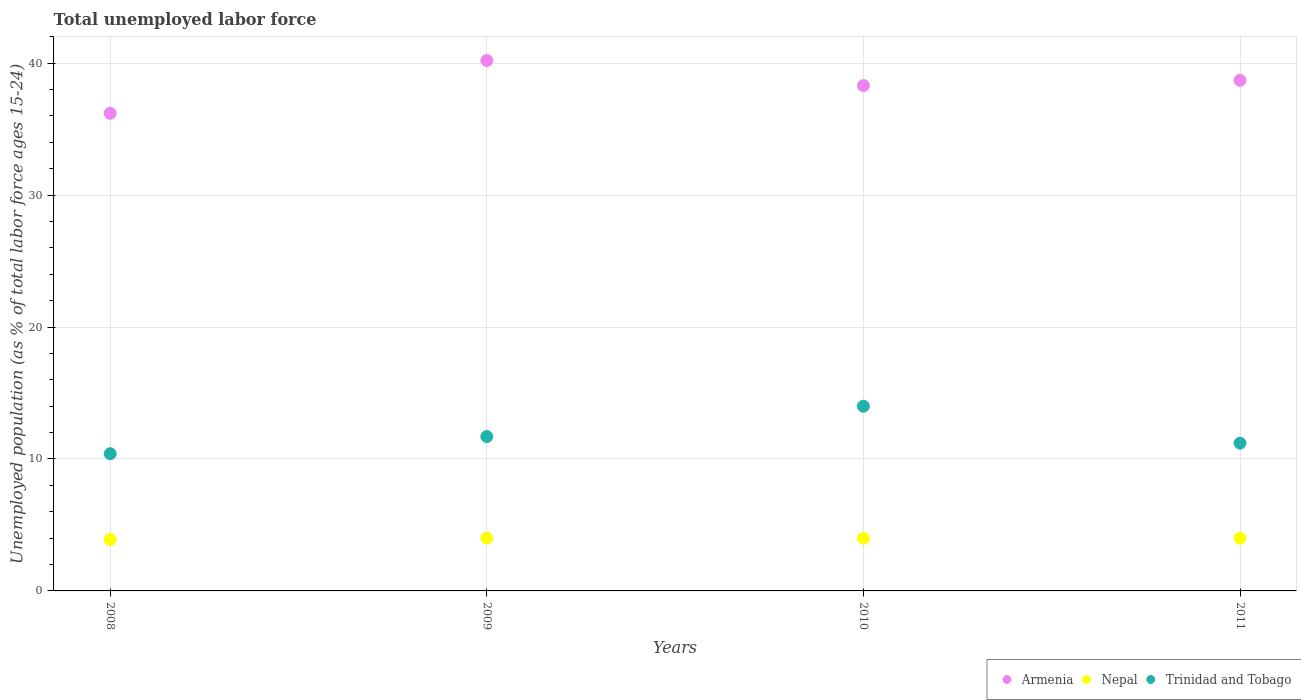How many different coloured dotlines are there?
Make the answer very short. 3. What is the percentage of unemployed population in in Trinidad and Tobago in 2009?
Offer a terse response. 11.7. Across all years, what is the maximum percentage of unemployed population in in Armenia?
Give a very brief answer. 40.2. Across all years, what is the minimum percentage of unemployed population in in Trinidad and Tobago?
Your answer should be compact. 10.4. What is the total percentage of unemployed population in in Trinidad and Tobago in the graph?
Keep it short and to the point. 47.3. What is the difference between the percentage of unemployed population in in Trinidad and Tobago in 2008 and that in 2009?
Give a very brief answer. -1.3. What is the difference between the percentage of unemployed population in in Trinidad and Tobago in 2011 and the percentage of unemployed population in in Nepal in 2008?
Your answer should be compact. 7.3. What is the average percentage of unemployed population in in Trinidad and Tobago per year?
Your answer should be compact. 11.82. In the year 2009, what is the difference between the percentage of unemployed population in in Trinidad and Tobago and percentage of unemployed population in in Nepal?
Your answer should be compact. 7.7. In how many years, is the percentage of unemployed population in in Armenia greater than 14 %?
Ensure brevity in your answer.  4. What is the ratio of the percentage of unemployed population in in Trinidad and Tobago in 2009 to that in 2011?
Ensure brevity in your answer.  1.04. In how many years, is the percentage of unemployed population in in Trinidad and Tobago greater than the average percentage of unemployed population in in Trinidad and Tobago taken over all years?
Make the answer very short. 1. Does the percentage of unemployed population in in Nepal monotonically increase over the years?
Offer a very short reply. No. Is the percentage of unemployed population in in Nepal strictly less than the percentage of unemployed population in in Trinidad and Tobago over the years?
Your answer should be very brief. Yes. How many years are there in the graph?
Your answer should be compact. 4. Does the graph contain grids?
Your response must be concise. Yes. How many legend labels are there?
Your response must be concise. 3. How are the legend labels stacked?
Your answer should be compact. Horizontal. What is the title of the graph?
Your answer should be very brief. Total unemployed labor force. Does "El Salvador" appear as one of the legend labels in the graph?
Your answer should be very brief. No. What is the label or title of the Y-axis?
Provide a succinct answer. Unemployed population (as % of total labor force ages 15-24). What is the Unemployed population (as % of total labor force ages 15-24) in Armenia in 2008?
Provide a short and direct response. 36.2. What is the Unemployed population (as % of total labor force ages 15-24) in Nepal in 2008?
Make the answer very short. 3.9. What is the Unemployed population (as % of total labor force ages 15-24) in Trinidad and Tobago in 2008?
Provide a short and direct response. 10.4. What is the Unemployed population (as % of total labor force ages 15-24) of Armenia in 2009?
Ensure brevity in your answer.  40.2. What is the Unemployed population (as % of total labor force ages 15-24) of Trinidad and Tobago in 2009?
Offer a very short reply. 11.7. What is the Unemployed population (as % of total labor force ages 15-24) of Armenia in 2010?
Make the answer very short. 38.3. What is the Unemployed population (as % of total labor force ages 15-24) in Nepal in 2010?
Offer a very short reply. 4. What is the Unemployed population (as % of total labor force ages 15-24) in Armenia in 2011?
Make the answer very short. 38.7. What is the Unemployed population (as % of total labor force ages 15-24) of Trinidad and Tobago in 2011?
Offer a terse response. 11.2. Across all years, what is the maximum Unemployed population (as % of total labor force ages 15-24) in Armenia?
Offer a very short reply. 40.2. Across all years, what is the maximum Unemployed population (as % of total labor force ages 15-24) of Nepal?
Ensure brevity in your answer.  4. Across all years, what is the maximum Unemployed population (as % of total labor force ages 15-24) in Trinidad and Tobago?
Make the answer very short. 14. Across all years, what is the minimum Unemployed population (as % of total labor force ages 15-24) in Armenia?
Provide a short and direct response. 36.2. Across all years, what is the minimum Unemployed population (as % of total labor force ages 15-24) of Nepal?
Offer a terse response. 3.9. Across all years, what is the minimum Unemployed population (as % of total labor force ages 15-24) in Trinidad and Tobago?
Offer a very short reply. 10.4. What is the total Unemployed population (as % of total labor force ages 15-24) of Armenia in the graph?
Provide a short and direct response. 153.4. What is the total Unemployed population (as % of total labor force ages 15-24) in Trinidad and Tobago in the graph?
Make the answer very short. 47.3. What is the difference between the Unemployed population (as % of total labor force ages 15-24) of Nepal in 2008 and that in 2009?
Keep it short and to the point. -0.1. What is the difference between the Unemployed population (as % of total labor force ages 15-24) in Nepal in 2008 and that in 2010?
Keep it short and to the point. -0.1. What is the difference between the Unemployed population (as % of total labor force ages 15-24) in Trinidad and Tobago in 2008 and that in 2010?
Your answer should be very brief. -3.6. What is the difference between the Unemployed population (as % of total labor force ages 15-24) in Nepal in 2008 and that in 2011?
Your answer should be very brief. -0.1. What is the difference between the Unemployed population (as % of total labor force ages 15-24) in Nepal in 2009 and that in 2010?
Ensure brevity in your answer.  0. What is the difference between the Unemployed population (as % of total labor force ages 15-24) in Nepal in 2009 and that in 2011?
Offer a terse response. 0. What is the difference between the Unemployed population (as % of total labor force ages 15-24) of Nepal in 2010 and that in 2011?
Your answer should be compact. 0. What is the difference between the Unemployed population (as % of total labor force ages 15-24) of Armenia in 2008 and the Unemployed population (as % of total labor force ages 15-24) of Nepal in 2009?
Offer a terse response. 32.2. What is the difference between the Unemployed population (as % of total labor force ages 15-24) of Armenia in 2008 and the Unemployed population (as % of total labor force ages 15-24) of Nepal in 2010?
Make the answer very short. 32.2. What is the difference between the Unemployed population (as % of total labor force ages 15-24) of Armenia in 2008 and the Unemployed population (as % of total labor force ages 15-24) of Trinidad and Tobago in 2010?
Make the answer very short. 22.2. What is the difference between the Unemployed population (as % of total labor force ages 15-24) of Nepal in 2008 and the Unemployed population (as % of total labor force ages 15-24) of Trinidad and Tobago in 2010?
Your answer should be very brief. -10.1. What is the difference between the Unemployed population (as % of total labor force ages 15-24) in Armenia in 2008 and the Unemployed population (as % of total labor force ages 15-24) in Nepal in 2011?
Your answer should be compact. 32.2. What is the difference between the Unemployed population (as % of total labor force ages 15-24) in Armenia in 2008 and the Unemployed population (as % of total labor force ages 15-24) in Trinidad and Tobago in 2011?
Keep it short and to the point. 25. What is the difference between the Unemployed population (as % of total labor force ages 15-24) in Nepal in 2008 and the Unemployed population (as % of total labor force ages 15-24) in Trinidad and Tobago in 2011?
Keep it short and to the point. -7.3. What is the difference between the Unemployed population (as % of total labor force ages 15-24) of Armenia in 2009 and the Unemployed population (as % of total labor force ages 15-24) of Nepal in 2010?
Make the answer very short. 36.2. What is the difference between the Unemployed population (as % of total labor force ages 15-24) in Armenia in 2009 and the Unemployed population (as % of total labor force ages 15-24) in Trinidad and Tobago in 2010?
Your response must be concise. 26.2. What is the difference between the Unemployed population (as % of total labor force ages 15-24) of Nepal in 2009 and the Unemployed population (as % of total labor force ages 15-24) of Trinidad and Tobago in 2010?
Make the answer very short. -10. What is the difference between the Unemployed population (as % of total labor force ages 15-24) in Armenia in 2009 and the Unemployed population (as % of total labor force ages 15-24) in Nepal in 2011?
Your answer should be compact. 36.2. What is the difference between the Unemployed population (as % of total labor force ages 15-24) of Armenia in 2010 and the Unemployed population (as % of total labor force ages 15-24) of Nepal in 2011?
Ensure brevity in your answer.  34.3. What is the difference between the Unemployed population (as % of total labor force ages 15-24) of Armenia in 2010 and the Unemployed population (as % of total labor force ages 15-24) of Trinidad and Tobago in 2011?
Provide a succinct answer. 27.1. What is the average Unemployed population (as % of total labor force ages 15-24) in Armenia per year?
Your answer should be very brief. 38.35. What is the average Unemployed population (as % of total labor force ages 15-24) of Nepal per year?
Offer a terse response. 3.98. What is the average Unemployed population (as % of total labor force ages 15-24) of Trinidad and Tobago per year?
Your response must be concise. 11.82. In the year 2008, what is the difference between the Unemployed population (as % of total labor force ages 15-24) in Armenia and Unemployed population (as % of total labor force ages 15-24) in Nepal?
Ensure brevity in your answer.  32.3. In the year 2008, what is the difference between the Unemployed population (as % of total labor force ages 15-24) of Armenia and Unemployed population (as % of total labor force ages 15-24) of Trinidad and Tobago?
Ensure brevity in your answer.  25.8. In the year 2008, what is the difference between the Unemployed population (as % of total labor force ages 15-24) in Nepal and Unemployed population (as % of total labor force ages 15-24) in Trinidad and Tobago?
Make the answer very short. -6.5. In the year 2009, what is the difference between the Unemployed population (as % of total labor force ages 15-24) in Armenia and Unemployed population (as % of total labor force ages 15-24) in Nepal?
Your answer should be very brief. 36.2. In the year 2009, what is the difference between the Unemployed population (as % of total labor force ages 15-24) of Armenia and Unemployed population (as % of total labor force ages 15-24) of Trinidad and Tobago?
Give a very brief answer. 28.5. In the year 2010, what is the difference between the Unemployed population (as % of total labor force ages 15-24) in Armenia and Unemployed population (as % of total labor force ages 15-24) in Nepal?
Offer a very short reply. 34.3. In the year 2010, what is the difference between the Unemployed population (as % of total labor force ages 15-24) of Armenia and Unemployed population (as % of total labor force ages 15-24) of Trinidad and Tobago?
Give a very brief answer. 24.3. In the year 2010, what is the difference between the Unemployed population (as % of total labor force ages 15-24) in Nepal and Unemployed population (as % of total labor force ages 15-24) in Trinidad and Tobago?
Your response must be concise. -10. In the year 2011, what is the difference between the Unemployed population (as % of total labor force ages 15-24) of Armenia and Unemployed population (as % of total labor force ages 15-24) of Nepal?
Ensure brevity in your answer.  34.7. What is the ratio of the Unemployed population (as % of total labor force ages 15-24) of Armenia in 2008 to that in 2009?
Give a very brief answer. 0.9. What is the ratio of the Unemployed population (as % of total labor force ages 15-24) of Trinidad and Tobago in 2008 to that in 2009?
Offer a very short reply. 0.89. What is the ratio of the Unemployed population (as % of total labor force ages 15-24) of Armenia in 2008 to that in 2010?
Your answer should be very brief. 0.95. What is the ratio of the Unemployed population (as % of total labor force ages 15-24) of Trinidad and Tobago in 2008 to that in 2010?
Your answer should be compact. 0.74. What is the ratio of the Unemployed population (as % of total labor force ages 15-24) in Armenia in 2008 to that in 2011?
Keep it short and to the point. 0.94. What is the ratio of the Unemployed population (as % of total labor force ages 15-24) of Nepal in 2008 to that in 2011?
Offer a terse response. 0.97. What is the ratio of the Unemployed population (as % of total labor force ages 15-24) in Trinidad and Tobago in 2008 to that in 2011?
Your response must be concise. 0.93. What is the ratio of the Unemployed population (as % of total labor force ages 15-24) of Armenia in 2009 to that in 2010?
Your answer should be compact. 1.05. What is the ratio of the Unemployed population (as % of total labor force ages 15-24) of Trinidad and Tobago in 2009 to that in 2010?
Ensure brevity in your answer.  0.84. What is the ratio of the Unemployed population (as % of total labor force ages 15-24) in Armenia in 2009 to that in 2011?
Ensure brevity in your answer.  1.04. What is the ratio of the Unemployed population (as % of total labor force ages 15-24) in Trinidad and Tobago in 2009 to that in 2011?
Offer a very short reply. 1.04. What is the ratio of the Unemployed population (as % of total labor force ages 15-24) of Armenia in 2010 to that in 2011?
Your answer should be very brief. 0.99. What is the ratio of the Unemployed population (as % of total labor force ages 15-24) of Nepal in 2010 to that in 2011?
Ensure brevity in your answer.  1. What is the difference between the highest and the second highest Unemployed population (as % of total labor force ages 15-24) of Trinidad and Tobago?
Keep it short and to the point. 2.3. What is the difference between the highest and the lowest Unemployed population (as % of total labor force ages 15-24) in Armenia?
Make the answer very short. 4. 